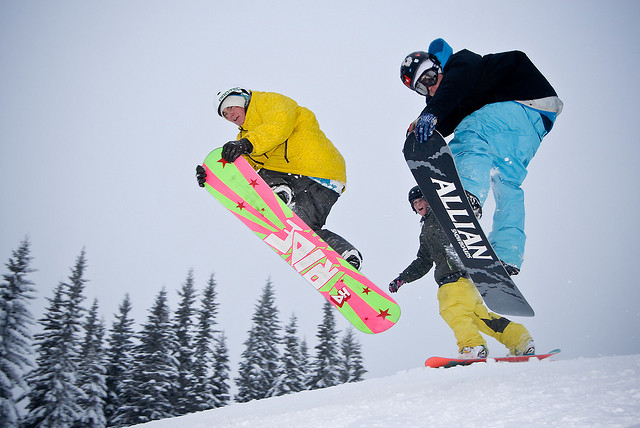Identify and read out the text in this image. RIDE DH ALLIAN 